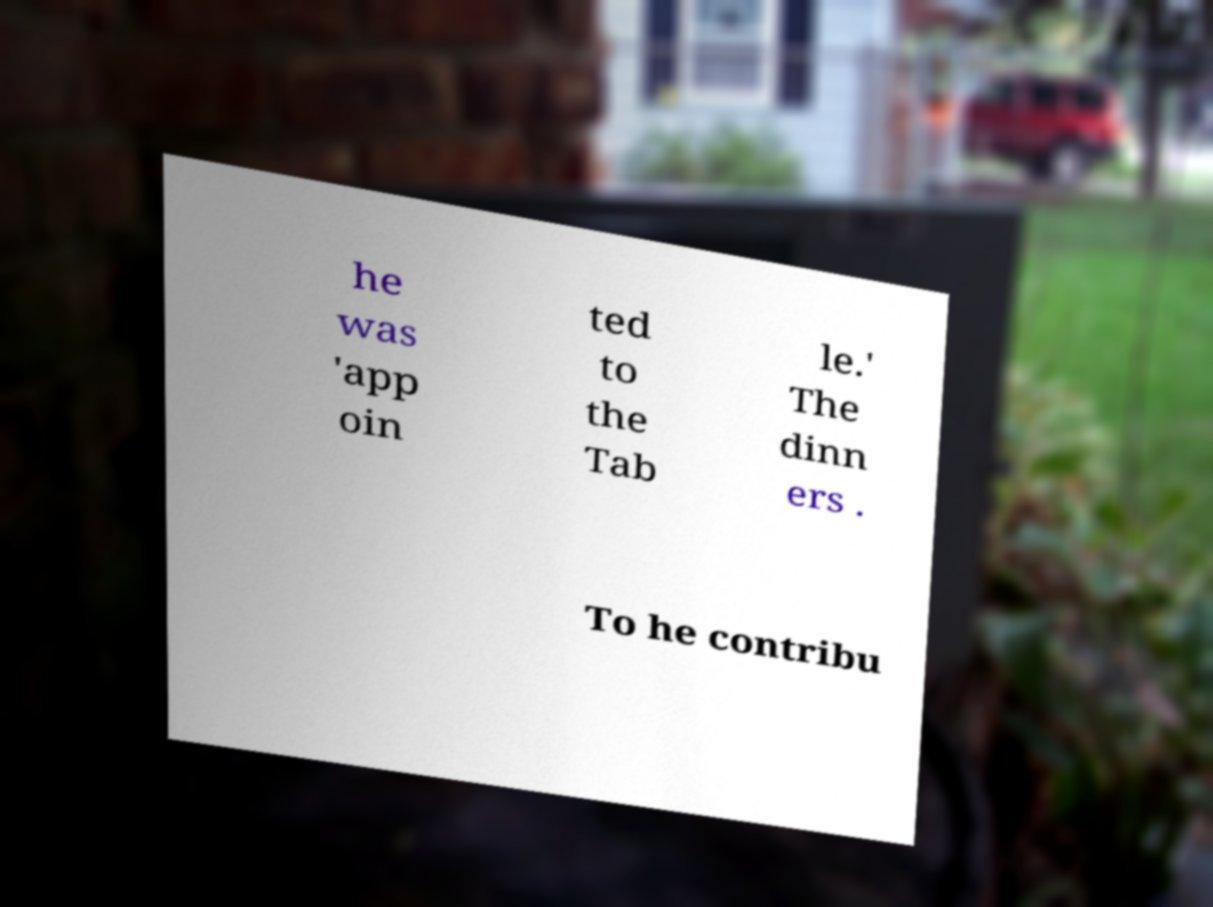I need the written content from this picture converted into text. Can you do that? he was 'app oin ted to the Tab le.' The dinn ers . To he contribu 